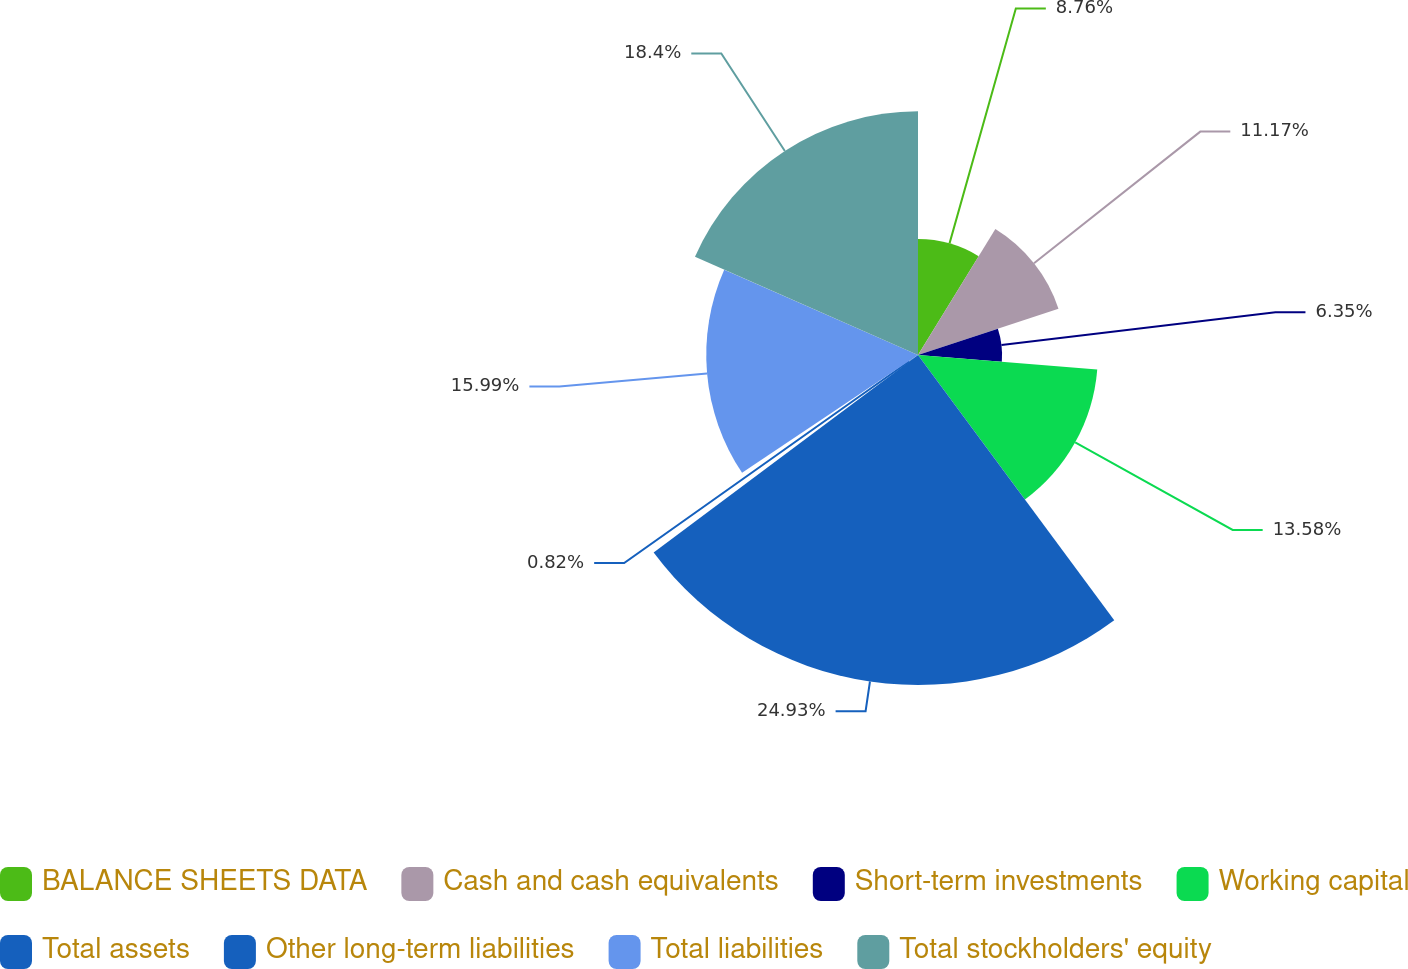<chart> <loc_0><loc_0><loc_500><loc_500><pie_chart><fcel>BALANCE SHEETS DATA<fcel>Cash and cash equivalents<fcel>Short-term investments<fcel>Working capital<fcel>Total assets<fcel>Other long-term liabilities<fcel>Total liabilities<fcel>Total stockholders' equity<nl><fcel>8.76%<fcel>11.17%<fcel>6.35%<fcel>13.58%<fcel>24.92%<fcel>0.82%<fcel>15.99%<fcel>18.4%<nl></chart> 